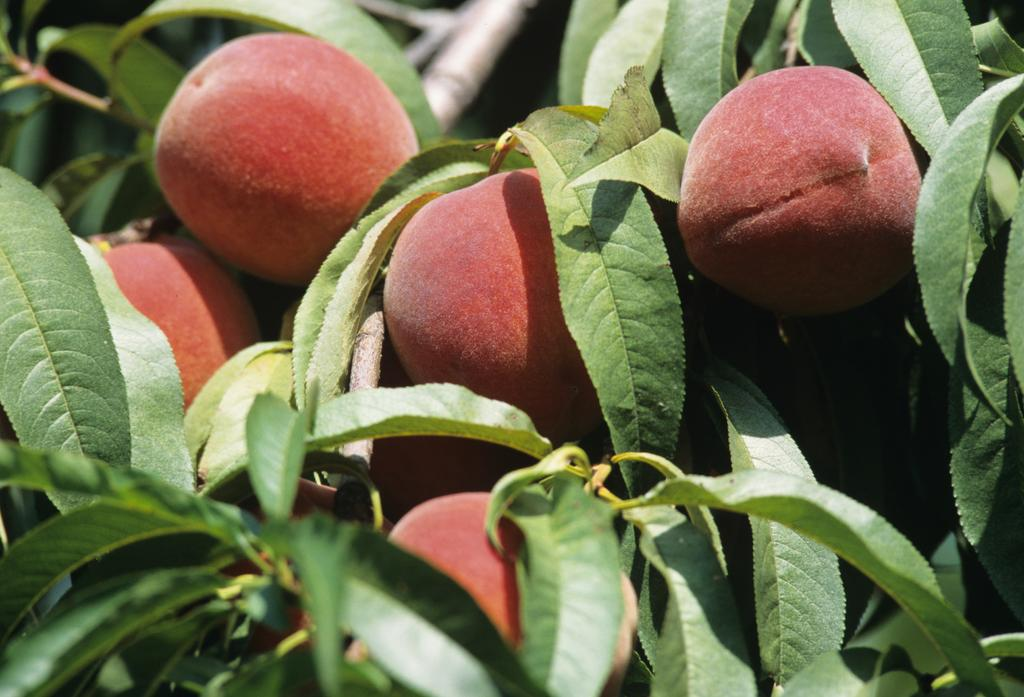What type of fruit can be seen on the plant in the image? There are peaches on a plant in the image. What type of instrument is being played by the spiders during the rainstorm in the image? There are no spiders, instruments, or rainstorm present in the image; it features peaches on a plant. 